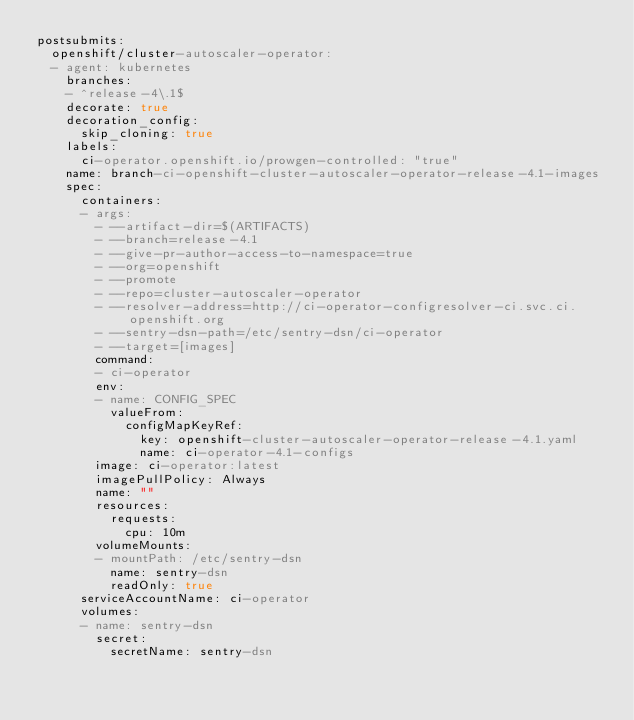<code> <loc_0><loc_0><loc_500><loc_500><_YAML_>postsubmits:
  openshift/cluster-autoscaler-operator:
  - agent: kubernetes
    branches:
    - ^release-4\.1$
    decorate: true
    decoration_config:
      skip_cloning: true
    labels:
      ci-operator.openshift.io/prowgen-controlled: "true"
    name: branch-ci-openshift-cluster-autoscaler-operator-release-4.1-images
    spec:
      containers:
      - args:
        - --artifact-dir=$(ARTIFACTS)
        - --branch=release-4.1
        - --give-pr-author-access-to-namespace=true
        - --org=openshift
        - --promote
        - --repo=cluster-autoscaler-operator
        - --resolver-address=http://ci-operator-configresolver-ci.svc.ci.openshift.org
        - --sentry-dsn-path=/etc/sentry-dsn/ci-operator
        - --target=[images]
        command:
        - ci-operator
        env:
        - name: CONFIG_SPEC
          valueFrom:
            configMapKeyRef:
              key: openshift-cluster-autoscaler-operator-release-4.1.yaml
              name: ci-operator-4.1-configs
        image: ci-operator:latest
        imagePullPolicy: Always
        name: ""
        resources:
          requests:
            cpu: 10m
        volumeMounts:
        - mountPath: /etc/sentry-dsn
          name: sentry-dsn
          readOnly: true
      serviceAccountName: ci-operator
      volumes:
      - name: sentry-dsn
        secret:
          secretName: sentry-dsn
</code> 